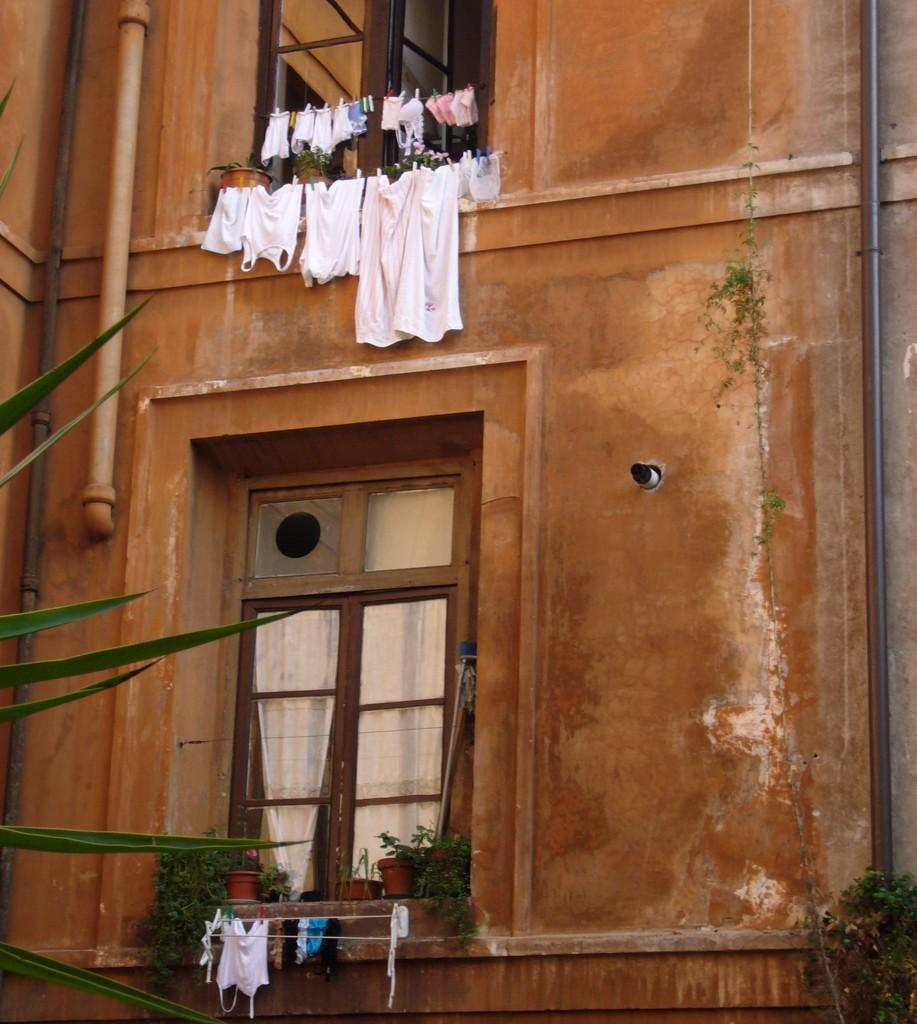What type of structure is depicted in the image? There is a two-floor building in the image. Are there any specific features of the building? Yes, the building has a window. What can be seen hanging outside the window? Clothes are hanging on a rope outside the window. What type of letters can be seen on the sidewalk in front of the building? There is no sidewalk or letters present in the image; it only features a two-floor building with a window and clothes hanging outside. 